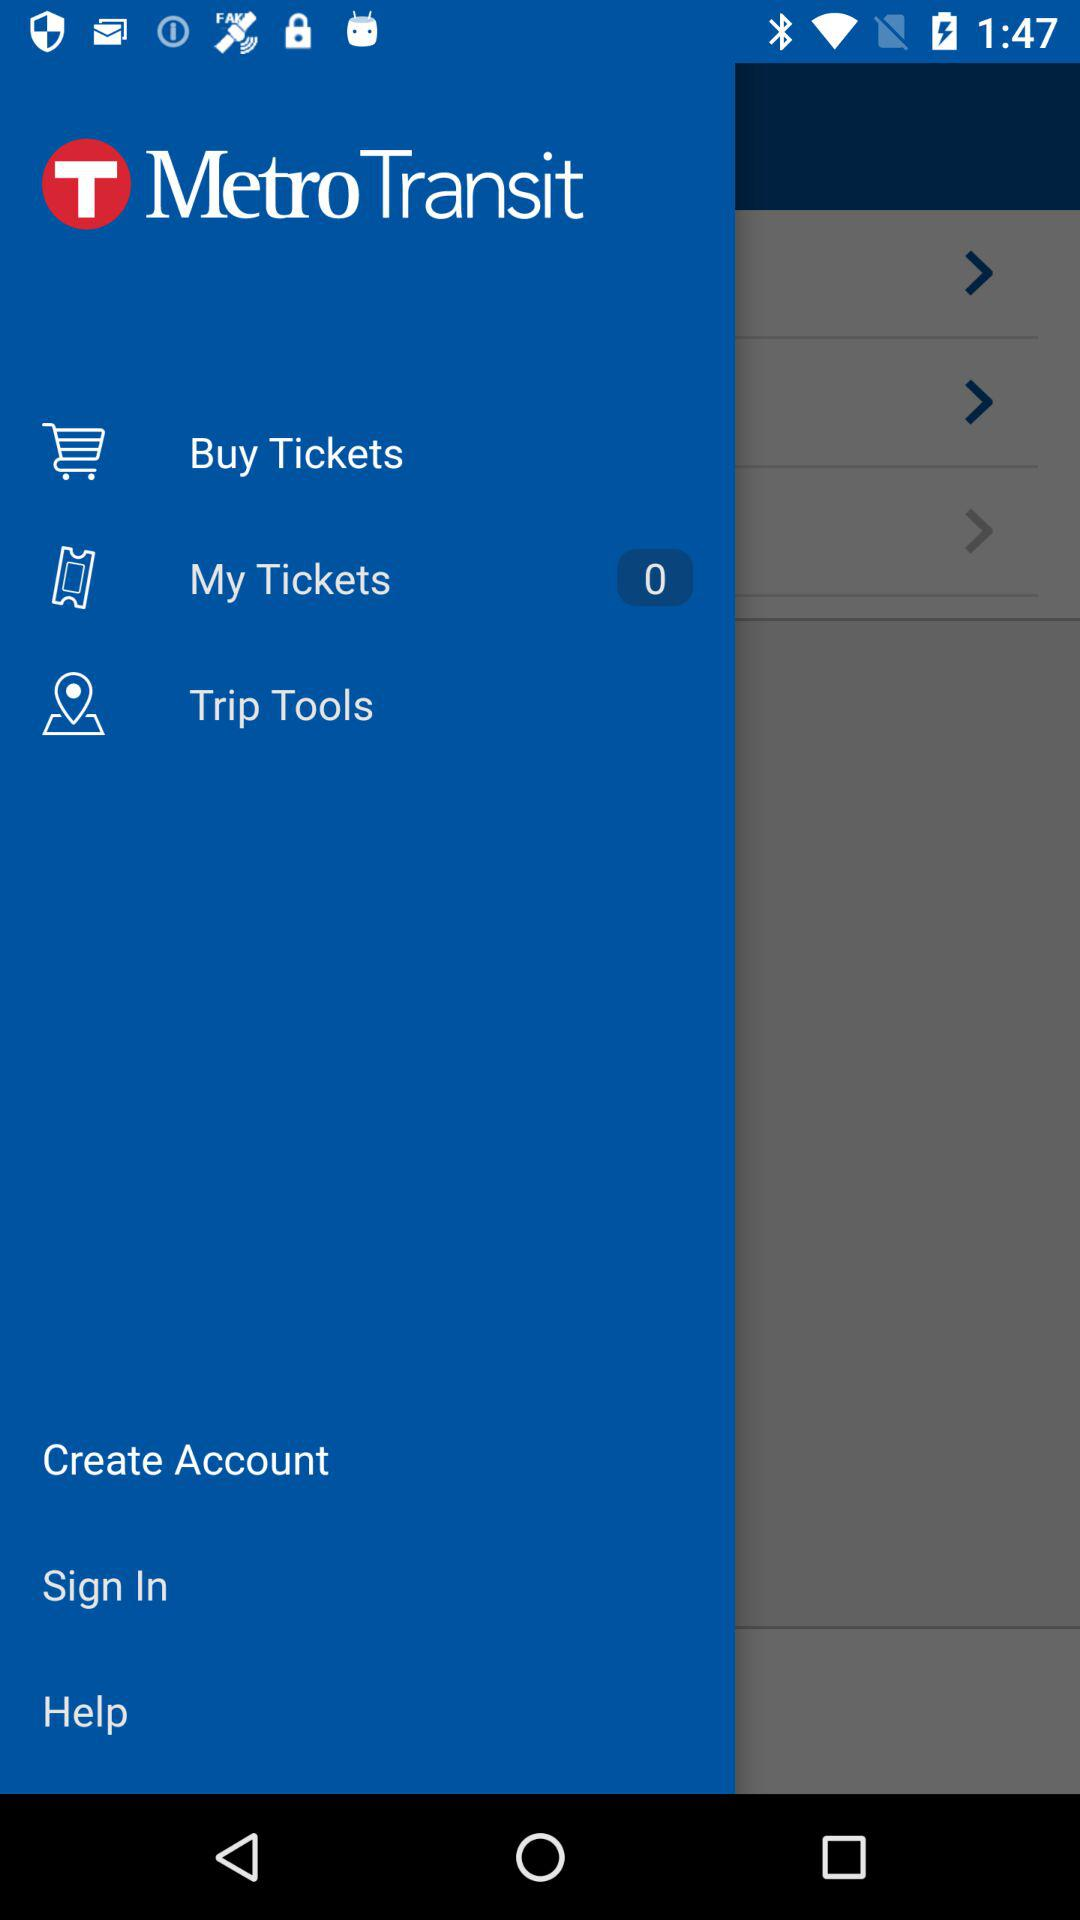How many tickets are shown there? There are zero tickets. 